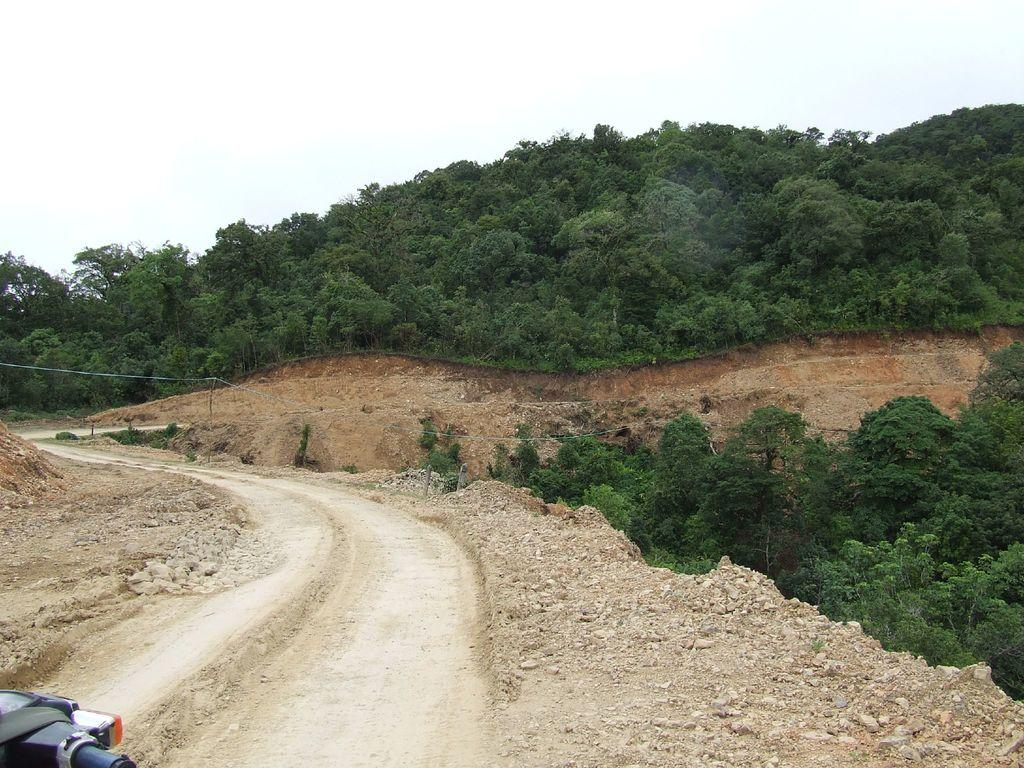What can be found on the left side of the image? There is a vehicle handle on the left side of the image. What is visible in the image? There is a way visible in the image. What type of natural elements are present in the image? Stones and trees are present in the image. What can be seen in the background of the image? The sky is plain and visible in the background of the image. Where is the scarecrow located in the image? There is no scarecrow present in the image. Can you provide an example of a vehicle that might have a handle like the one shown in the image? It is difficult to determine the specific type of vehicle from the handle alone, but it could belong to a car, truck, or van. 